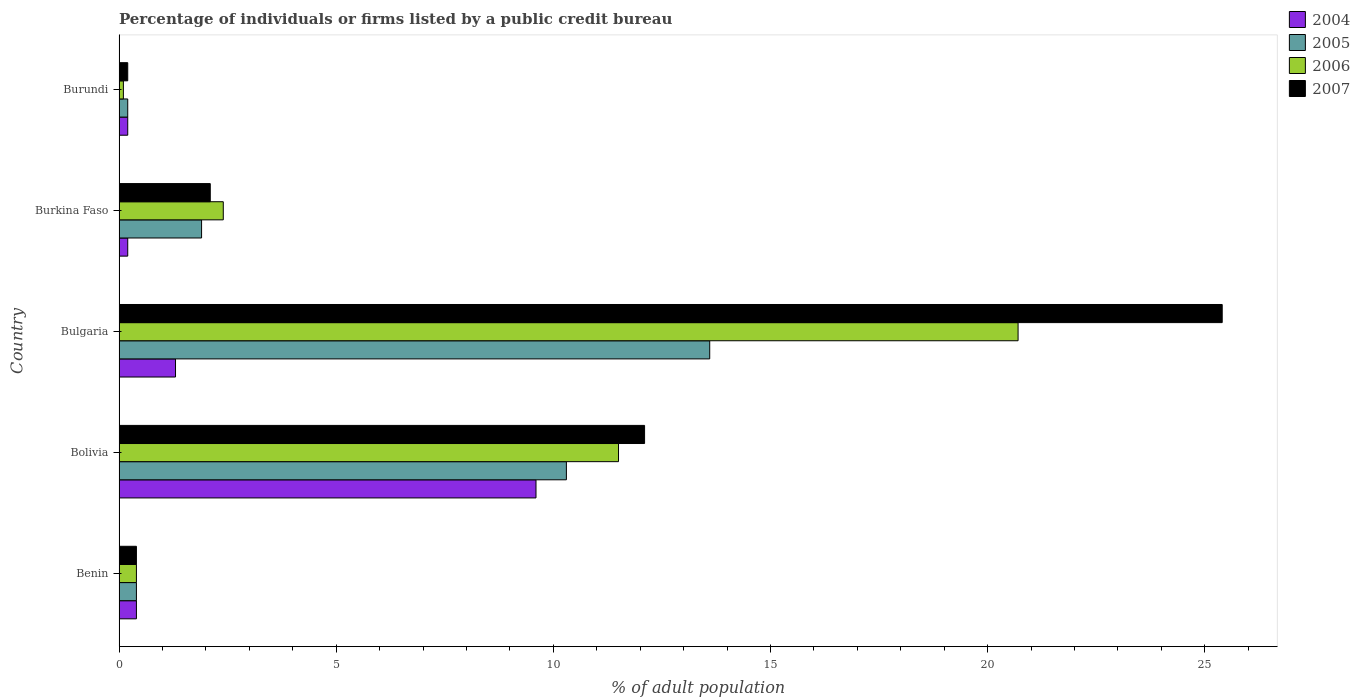How many different coloured bars are there?
Provide a succinct answer. 4. How many groups of bars are there?
Your answer should be compact. 5. How many bars are there on the 1st tick from the bottom?
Provide a succinct answer. 4. What is the label of the 5th group of bars from the top?
Offer a very short reply. Benin. In how many cases, is the number of bars for a given country not equal to the number of legend labels?
Give a very brief answer. 0. What is the percentage of population listed by a public credit bureau in 2004 in Burkina Faso?
Keep it short and to the point. 0.2. Across all countries, what is the maximum percentage of population listed by a public credit bureau in 2006?
Your answer should be very brief. 20.7. Across all countries, what is the minimum percentage of population listed by a public credit bureau in 2007?
Your answer should be very brief. 0.2. In which country was the percentage of population listed by a public credit bureau in 2005 minimum?
Make the answer very short. Burundi. What is the total percentage of population listed by a public credit bureau in 2006 in the graph?
Provide a short and direct response. 35.1. What is the difference between the percentage of population listed by a public credit bureau in 2007 in Burkina Faso and the percentage of population listed by a public credit bureau in 2006 in Bulgaria?
Offer a very short reply. -18.6. What is the average percentage of population listed by a public credit bureau in 2005 per country?
Your answer should be very brief. 5.28. What is the difference between the percentage of population listed by a public credit bureau in 2006 and percentage of population listed by a public credit bureau in 2004 in Burundi?
Your answer should be compact. -0.1. What is the ratio of the percentage of population listed by a public credit bureau in 2005 in Bolivia to that in Burkina Faso?
Provide a succinct answer. 5.42. Is the percentage of population listed by a public credit bureau in 2006 in Benin less than that in Burkina Faso?
Offer a terse response. Yes. Is the difference between the percentage of population listed by a public credit bureau in 2006 in Bulgaria and Burkina Faso greater than the difference between the percentage of population listed by a public credit bureau in 2004 in Bulgaria and Burkina Faso?
Provide a short and direct response. Yes. What is the difference between the highest and the second highest percentage of population listed by a public credit bureau in 2004?
Your response must be concise. 8.3. What is the difference between the highest and the lowest percentage of population listed by a public credit bureau in 2006?
Offer a very short reply. 20.6. What does the 4th bar from the bottom in Bulgaria represents?
Your answer should be very brief. 2007. Are all the bars in the graph horizontal?
Provide a short and direct response. Yes. How many countries are there in the graph?
Make the answer very short. 5. Does the graph contain any zero values?
Ensure brevity in your answer.  No. Does the graph contain grids?
Keep it short and to the point. No. How are the legend labels stacked?
Provide a short and direct response. Vertical. What is the title of the graph?
Make the answer very short. Percentage of individuals or firms listed by a public credit bureau. What is the label or title of the X-axis?
Keep it short and to the point. % of adult population. What is the label or title of the Y-axis?
Your answer should be compact. Country. What is the % of adult population in 2004 in Benin?
Offer a terse response. 0.4. What is the % of adult population in 2007 in Benin?
Provide a succinct answer. 0.4. What is the % of adult population of 2004 in Bolivia?
Ensure brevity in your answer.  9.6. What is the % of adult population of 2005 in Bolivia?
Ensure brevity in your answer.  10.3. What is the % of adult population in 2007 in Bolivia?
Your answer should be very brief. 12.1. What is the % of adult population of 2006 in Bulgaria?
Give a very brief answer. 20.7. What is the % of adult population in 2007 in Bulgaria?
Your answer should be compact. 25.4. What is the % of adult population of 2005 in Burkina Faso?
Offer a very short reply. 1.9. What is the % of adult population in 2006 in Burkina Faso?
Offer a terse response. 2.4. What is the % of adult population of 2006 in Burundi?
Keep it short and to the point. 0.1. Across all countries, what is the maximum % of adult population in 2004?
Your response must be concise. 9.6. Across all countries, what is the maximum % of adult population in 2006?
Offer a terse response. 20.7. Across all countries, what is the maximum % of adult population of 2007?
Your answer should be compact. 25.4. Across all countries, what is the minimum % of adult population in 2005?
Give a very brief answer. 0.2. What is the total % of adult population in 2005 in the graph?
Your response must be concise. 26.4. What is the total % of adult population in 2006 in the graph?
Give a very brief answer. 35.1. What is the total % of adult population of 2007 in the graph?
Give a very brief answer. 40.2. What is the difference between the % of adult population of 2006 in Benin and that in Bolivia?
Keep it short and to the point. -11.1. What is the difference between the % of adult population in 2006 in Benin and that in Bulgaria?
Give a very brief answer. -20.3. What is the difference between the % of adult population in 2007 in Benin and that in Bulgaria?
Offer a very short reply. -25. What is the difference between the % of adult population in 2006 in Benin and that in Burkina Faso?
Your response must be concise. -2. What is the difference between the % of adult population of 2007 in Benin and that in Burkina Faso?
Provide a succinct answer. -1.7. What is the difference between the % of adult population of 2007 in Benin and that in Burundi?
Your answer should be very brief. 0.2. What is the difference between the % of adult population of 2005 in Bolivia and that in Bulgaria?
Your response must be concise. -3.3. What is the difference between the % of adult population of 2004 in Bolivia and that in Burkina Faso?
Keep it short and to the point. 9.4. What is the difference between the % of adult population in 2006 in Bolivia and that in Burkina Faso?
Your response must be concise. 9.1. What is the difference between the % of adult population in 2007 in Bolivia and that in Burkina Faso?
Make the answer very short. 10. What is the difference between the % of adult population in 2005 in Bolivia and that in Burundi?
Your answer should be very brief. 10.1. What is the difference between the % of adult population of 2006 in Bolivia and that in Burundi?
Your answer should be very brief. 11.4. What is the difference between the % of adult population in 2007 in Bolivia and that in Burundi?
Make the answer very short. 11.9. What is the difference between the % of adult population in 2004 in Bulgaria and that in Burkina Faso?
Ensure brevity in your answer.  1.1. What is the difference between the % of adult population of 2005 in Bulgaria and that in Burkina Faso?
Keep it short and to the point. 11.7. What is the difference between the % of adult population of 2006 in Bulgaria and that in Burkina Faso?
Your answer should be very brief. 18.3. What is the difference between the % of adult population in 2007 in Bulgaria and that in Burkina Faso?
Keep it short and to the point. 23.3. What is the difference between the % of adult population in 2004 in Bulgaria and that in Burundi?
Keep it short and to the point. 1.1. What is the difference between the % of adult population of 2006 in Bulgaria and that in Burundi?
Make the answer very short. 20.6. What is the difference between the % of adult population in 2007 in Bulgaria and that in Burundi?
Ensure brevity in your answer.  25.2. What is the difference between the % of adult population in 2004 in Burkina Faso and that in Burundi?
Provide a succinct answer. 0. What is the difference between the % of adult population in 2005 in Burkina Faso and that in Burundi?
Provide a short and direct response. 1.7. What is the difference between the % of adult population in 2006 in Burkina Faso and that in Burundi?
Provide a succinct answer. 2.3. What is the difference between the % of adult population in 2007 in Burkina Faso and that in Burundi?
Ensure brevity in your answer.  1.9. What is the difference between the % of adult population of 2004 in Benin and the % of adult population of 2006 in Bulgaria?
Give a very brief answer. -20.3. What is the difference between the % of adult population of 2005 in Benin and the % of adult population of 2006 in Bulgaria?
Provide a short and direct response. -20.3. What is the difference between the % of adult population of 2005 in Benin and the % of adult population of 2007 in Bulgaria?
Offer a terse response. -25. What is the difference between the % of adult population of 2004 in Benin and the % of adult population of 2005 in Burkina Faso?
Make the answer very short. -1.5. What is the difference between the % of adult population in 2005 in Benin and the % of adult population in 2006 in Burkina Faso?
Offer a very short reply. -2. What is the difference between the % of adult population of 2006 in Benin and the % of adult population of 2007 in Burkina Faso?
Ensure brevity in your answer.  -1.7. What is the difference between the % of adult population in 2004 in Benin and the % of adult population in 2005 in Burundi?
Provide a short and direct response. 0.2. What is the difference between the % of adult population in 2004 in Benin and the % of adult population in 2006 in Burundi?
Give a very brief answer. 0.3. What is the difference between the % of adult population in 2005 in Benin and the % of adult population in 2007 in Burundi?
Provide a short and direct response. 0.2. What is the difference between the % of adult population in 2004 in Bolivia and the % of adult population in 2005 in Bulgaria?
Your answer should be compact. -4. What is the difference between the % of adult population in 2004 in Bolivia and the % of adult population in 2006 in Bulgaria?
Your answer should be very brief. -11.1. What is the difference between the % of adult population in 2004 in Bolivia and the % of adult population in 2007 in Bulgaria?
Offer a very short reply. -15.8. What is the difference between the % of adult population in 2005 in Bolivia and the % of adult population in 2007 in Bulgaria?
Give a very brief answer. -15.1. What is the difference between the % of adult population of 2006 in Bolivia and the % of adult population of 2007 in Bulgaria?
Make the answer very short. -13.9. What is the difference between the % of adult population in 2004 in Bolivia and the % of adult population in 2005 in Burkina Faso?
Your response must be concise. 7.7. What is the difference between the % of adult population of 2004 in Bolivia and the % of adult population of 2006 in Burkina Faso?
Your response must be concise. 7.2. What is the difference between the % of adult population in 2004 in Bolivia and the % of adult population in 2007 in Burkina Faso?
Your answer should be compact. 7.5. What is the difference between the % of adult population of 2005 in Bolivia and the % of adult population of 2006 in Burkina Faso?
Provide a succinct answer. 7.9. What is the difference between the % of adult population of 2005 in Bolivia and the % of adult population of 2007 in Burkina Faso?
Give a very brief answer. 8.2. What is the difference between the % of adult population in 2004 in Bolivia and the % of adult population in 2005 in Burundi?
Your answer should be very brief. 9.4. What is the difference between the % of adult population in 2004 in Bolivia and the % of adult population in 2006 in Burundi?
Your answer should be very brief. 9.5. What is the difference between the % of adult population in 2004 in Bolivia and the % of adult population in 2007 in Burundi?
Keep it short and to the point. 9.4. What is the difference between the % of adult population of 2005 in Bolivia and the % of adult population of 2006 in Burundi?
Make the answer very short. 10.2. What is the difference between the % of adult population of 2006 in Bolivia and the % of adult population of 2007 in Burundi?
Keep it short and to the point. 11.3. What is the difference between the % of adult population of 2004 in Bulgaria and the % of adult population of 2006 in Burkina Faso?
Offer a terse response. -1.1. What is the difference between the % of adult population in 2005 in Bulgaria and the % of adult population in 2006 in Burkina Faso?
Your answer should be compact. 11.2. What is the difference between the % of adult population in 2004 in Bulgaria and the % of adult population in 2006 in Burundi?
Your answer should be compact. 1.2. What is the difference between the % of adult population of 2004 in Bulgaria and the % of adult population of 2007 in Burundi?
Offer a very short reply. 1.1. What is the difference between the % of adult population in 2005 in Bulgaria and the % of adult population in 2007 in Burundi?
Make the answer very short. 13.4. What is the difference between the % of adult population in 2006 in Bulgaria and the % of adult population in 2007 in Burundi?
Your answer should be very brief. 20.5. What is the difference between the % of adult population of 2006 in Burkina Faso and the % of adult population of 2007 in Burundi?
Make the answer very short. 2.2. What is the average % of adult population in 2004 per country?
Give a very brief answer. 2.34. What is the average % of adult population of 2005 per country?
Offer a terse response. 5.28. What is the average % of adult population in 2006 per country?
Make the answer very short. 7.02. What is the average % of adult population of 2007 per country?
Your answer should be compact. 8.04. What is the difference between the % of adult population in 2004 and % of adult population in 2005 in Benin?
Provide a short and direct response. 0. What is the difference between the % of adult population of 2005 and % of adult population of 2007 in Benin?
Provide a succinct answer. 0. What is the difference between the % of adult population of 2006 and % of adult population of 2007 in Benin?
Make the answer very short. 0. What is the difference between the % of adult population of 2004 and % of adult population of 2005 in Bolivia?
Your answer should be very brief. -0.7. What is the difference between the % of adult population in 2005 and % of adult population in 2006 in Bolivia?
Your response must be concise. -1.2. What is the difference between the % of adult population of 2006 and % of adult population of 2007 in Bolivia?
Provide a succinct answer. -0.6. What is the difference between the % of adult population of 2004 and % of adult population of 2005 in Bulgaria?
Keep it short and to the point. -12.3. What is the difference between the % of adult population in 2004 and % of adult population in 2006 in Bulgaria?
Offer a terse response. -19.4. What is the difference between the % of adult population in 2004 and % of adult population in 2007 in Bulgaria?
Offer a very short reply. -24.1. What is the difference between the % of adult population of 2005 and % of adult population of 2006 in Bulgaria?
Keep it short and to the point. -7.1. What is the difference between the % of adult population of 2004 and % of adult population of 2005 in Burkina Faso?
Offer a terse response. -1.7. What is the difference between the % of adult population in 2004 and % of adult population in 2007 in Burkina Faso?
Ensure brevity in your answer.  -1.9. What is the difference between the % of adult population of 2006 and % of adult population of 2007 in Burkina Faso?
Your answer should be compact. 0.3. What is the difference between the % of adult population of 2004 and % of adult population of 2005 in Burundi?
Make the answer very short. 0. What is the difference between the % of adult population of 2004 and % of adult population of 2007 in Burundi?
Your response must be concise. 0. What is the ratio of the % of adult population of 2004 in Benin to that in Bolivia?
Your response must be concise. 0.04. What is the ratio of the % of adult population of 2005 in Benin to that in Bolivia?
Your answer should be very brief. 0.04. What is the ratio of the % of adult population in 2006 in Benin to that in Bolivia?
Give a very brief answer. 0.03. What is the ratio of the % of adult population of 2007 in Benin to that in Bolivia?
Offer a terse response. 0.03. What is the ratio of the % of adult population in 2004 in Benin to that in Bulgaria?
Provide a succinct answer. 0.31. What is the ratio of the % of adult population in 2005 in Benin to that in Bulgaria?
Your response must be concise. 0.03. What is the ratio of the % of adult population of 2006 in Benin to that in Bulgaria?
Offer a very short reply. 0.02. What is the ratio of the % of adult population in 2007 in Benin to that in Bulgaria?
Give a very brief answer. 0.02. What is the ratio of the % of adult population in 2005 in Benin to that in Burkina Faso?
Provide a succinct answer. 0.21. What is the ratio of the % of adult population of 2007 in Benin to that in Burkina Faso?
Your answer should be compact. 0.19. What is the ratio of the % of adult population in 2004 in Benin to that in Burundi?
Provide a short and direct response. 2. What is the ratio of the % of adult population in 2006 in Benin to that in Burundi?
Your response must be concise. 4. What is the ratio of the % of adult population of 2007 in Benin to that in Burundi?
Your response must be concise. 2. What is the ratio of the % of adult population of 2004 in Bolivia to that in Bulgaria?
Keep it short and to the point. 7.38. What is the ratio of the % of adult population of 2005 in Bolivia to that in Bulgaria?
Your answer should be very brief. 0.76. What is the ratio of the % of adult population in 2006 in Bolivia to that in Bulgaria?
Offer a very short reply. 0.56. What is the ratio of the % of adult population of 2007 in Bolivia to that in Bulgaria?
Your answer should be very brief. 0.48. What is the ratio of the % of adult population in 2004 in Bolivia to that in Burkina Faso?
Offer a terse response. 48. What is the ratio of the % of adult population of 2005 in Bolivia to that in Burkina Faso?
Make the answer very short. 5.42. What is the ratio of the % of adult population of 2006 in Bolivia to that in Burkina Faso?
Keep it short and to the point. 4.79. What is the ratio of the % of adult population in 2007 in Bolivia to that in Burkina Faso?
Provide a succinct answer. 5.76. What is the ratio of the % of adult population in 2004 in Bolivia to that in Burundi?
Your response must be concise. 48. What is the ratio of the % of adult population in 2005 in Bolivia to that in Burundi?
Offer a very short reply. 51.5. What is the ratio of the % of adult population in 2006 in Bolivia to that in Burundi?
Keep it short and to the point. 115. What is the ratio of the % of adult population of 2007 in Bolivia to that in Burundi?
Your answer should be compact. 60.5. What is the ratio of the % of adult population in 2005 in Bulgaria to that in Burkina Faso?
Provide a short and direct response. 7.16. What is the ratio of the % of adult population in 2006 in Bulgaria to that in Burkina Faso?
Keep it short and to the point. 8.62. What is the ratio of the % of adult population in 2007 in Bulgaria to that in Burkina Faso?
Your response must be concise. 12.1. What is the ratio of the % of adult population of 2004 in Bulgaria to that in Burundi?
Make the answer very short. 6.5. What is the ratio of the % of adult population of 2005 in Bulgaria to that in Burundi?
Provide a short and direct response. 68. What is the ratio of the % of adult population in 2006 in Bulgaria to that in Burundi?
Your answer should be compact. 207. What is the ratio of the % of adult population in 2007 in Bulgaria to that in Burundi?
Offer a very short reply. 127. What is the ratio of the % of adult population of 2004 in Burkina Faso to that in Burundi?
Make the answer very short. 1. What is the ratio of the % of adult population in 2005 in Burkina Faso to that in Burundi?
Give a very brief answer. 9.5. What is the ratio of the % of adult population in 2006 in Burkina Faso to that in Burundi?
Offer a very short reply. 24. What is the difference between the highest and the lowest % of adult population in 2004?
Provide a short and direct response. 9.4. What is the difference between the highest and the lowest % of adult population in 2006?
Offer a terse response. 20.6. What is the difference between the highest and the lowest % of adult population of 2007?
Ensure brevity in your answer.  25.2. 